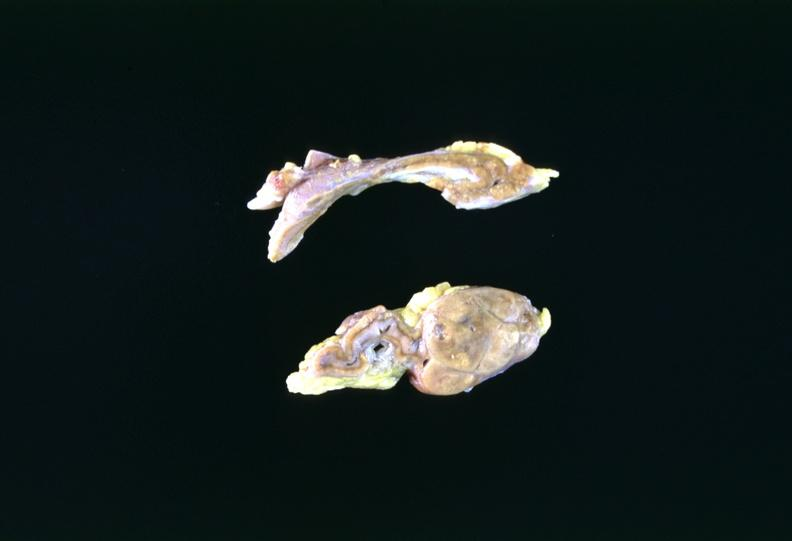s endocrine present?
Answer the question using a single word or phrase. Yes 